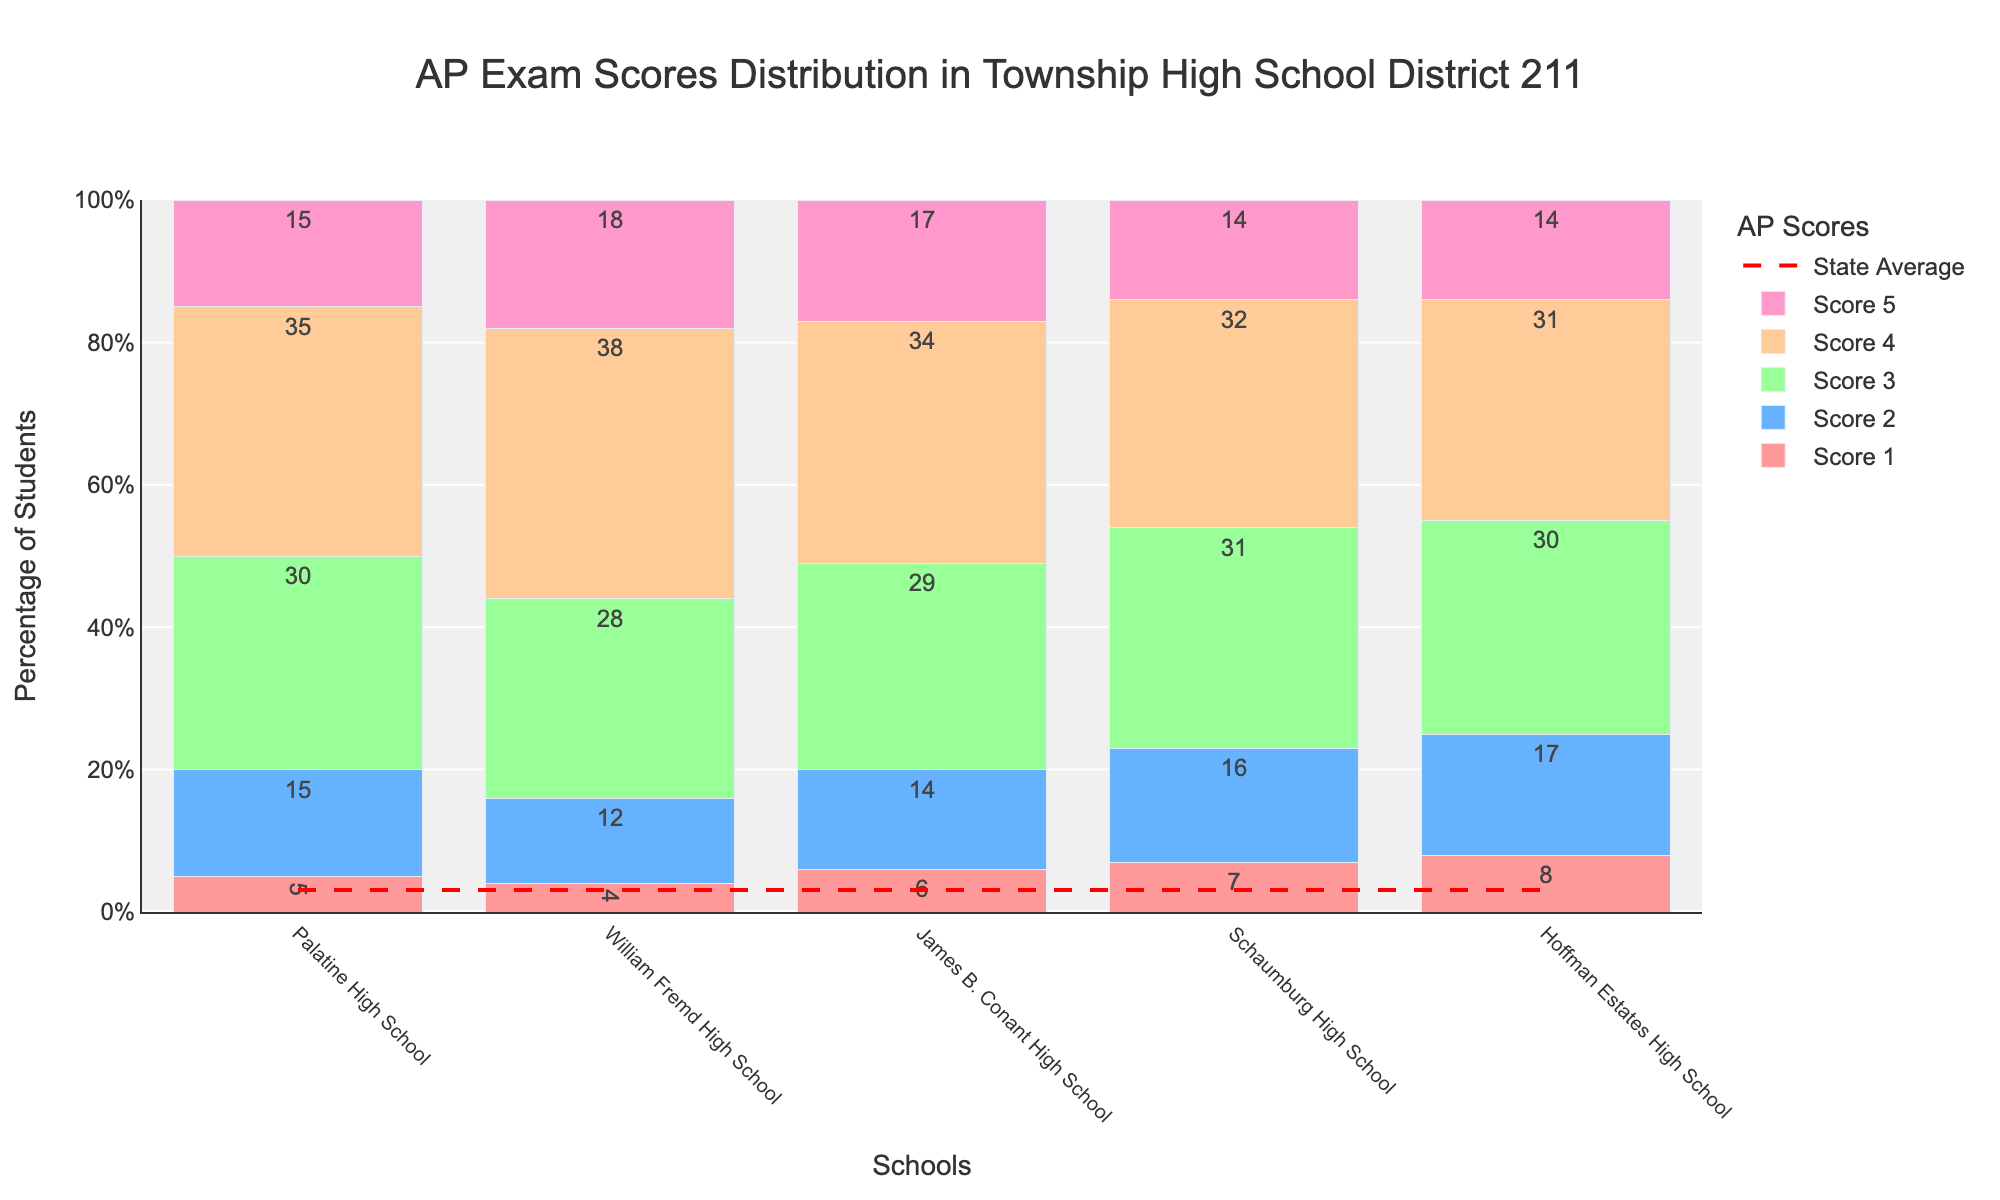What is the title of the plot? The title of the plot is located at the top center of the figure.
Answer: AP Exam Scores Distribution in Township High School District 211 What is the percentage of students who scored a 4 at Palatine High School? Look at the bar segment representing Score 4 for Palatine High School; it's labeled with its value.
Answer: 35 What school has the highest percentage of students scoring a 5? Compare the height and labels of the bar segments representing Score 5 for each school.
Answer: William Fremd High School Which AP score category has the smallest number of students in Schaumburg High School? Examine the height and labels of the bar segments for Schaumburg High School to find the smallest one.
Answer: Score 5 How does the percentage of students scoring a 3 at James B. Conant High School compare to those at Hoffman Estates High School? Compare the heights and labels of the bar segments representing Score 3 for both schools.
Answer: James B. Conant has a slightly higher percentage (29 vs. 30) Which school has the closest average AP score to the state average? Compare the overall height of each school's stacked bars and assess their proximity to the state average line.
Answer: William Fremd High School What is the total percentage of students scoring 1 or 2 at Palatine High School? Add up the percentages of students scoring 1 (5) and 2 (15) at Palatine High School.
Answer: 20% How many schools have a higher percentage of students scoring 4 than the state average? Compare the Score 4 bar segments of each school to the state average (25%) and count those higher.
Answer: 4 schools Is the percentage of students scoring 3 at Schaumburg High School higher, lower, or equal to the state average? Compare the Score 3 bar segment for Schaumburg High School to the state average (30%).
Answer: Higher (31%) Which school has the highest combined percentage of students scoring 4 and 5? Sum the percentages of students scoring 4 and 5 for each school, then compare totals.
Answer: William Fremd High School 